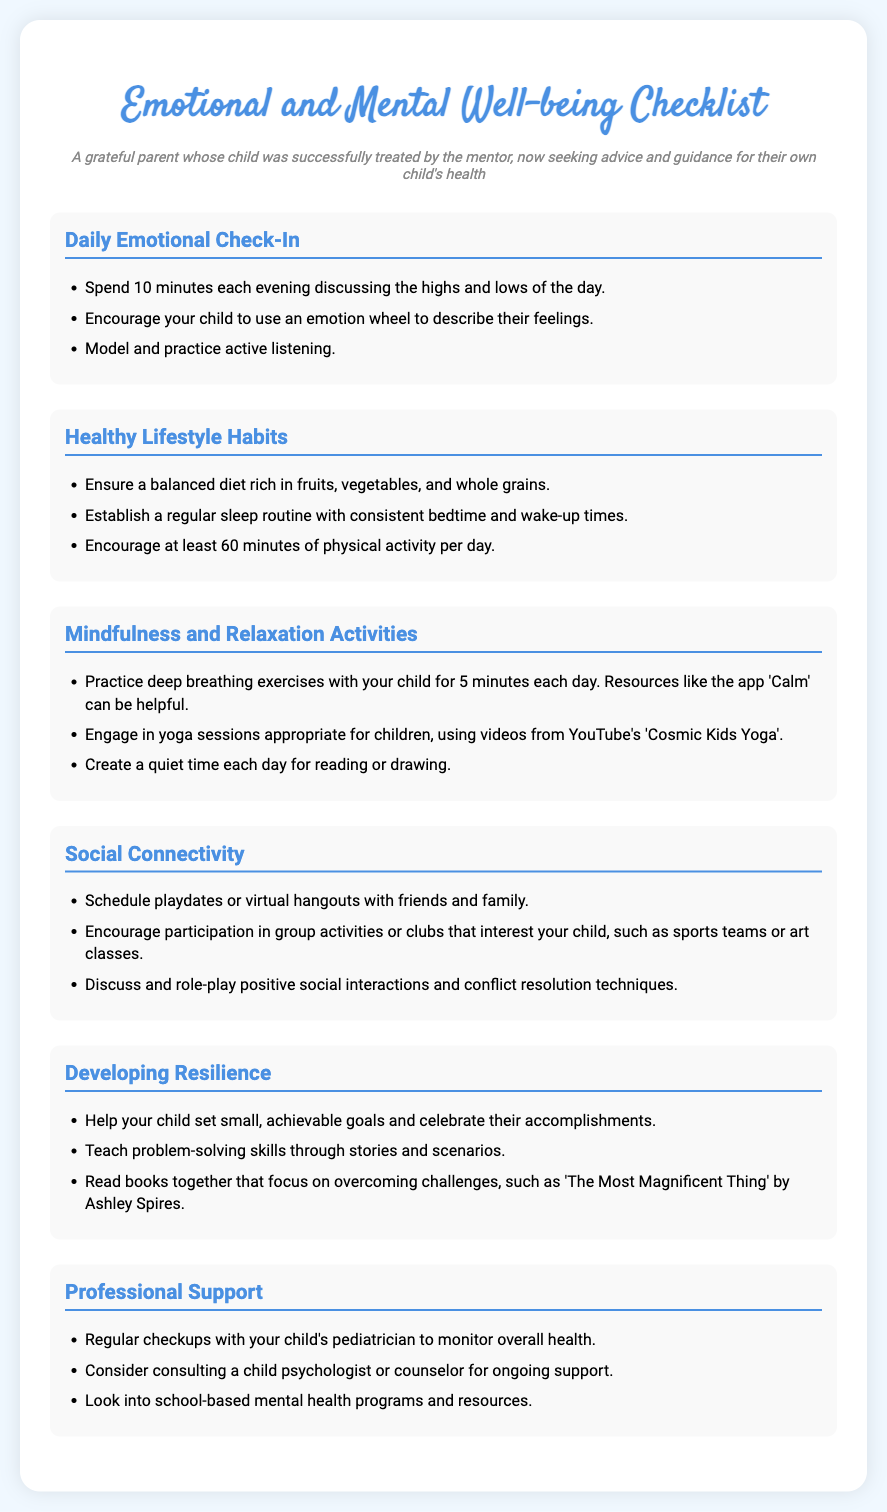what is the title of the document? The title is prominently displayed at the top of the document, indicating its main subject.
Answer: Emotional and Mental Well-being Checklist how many sections are there in the checklist? The document lists individual sections, which can be counted to find the total.
Answer: 6 what activity is recommended for daily emotional check-in? Each section provides specific activities that can be performed to enhance emotional well-being.
Answer: Discuss the highs and lows of the day which resource is suggested for deep breathing exercises? The document references a specific app that may help facilitate mindfulness activities.
Answer: Calm what type of activities should be encouraged for social connectivity? The document describes types of interactions that support children's social skills.
Answer: Playdates what is one book mentioned to help develop resilience? The document suggests specific literature that deals with overcoming challenges to bolster resilience.
Answer: The Most Magnificent Thing what is the recommended duration of physical activity per day? The official recommendations for physical activity duration for children are mentioned in the health habits section.
Answer: 60 minutes what professional support is suggested for ongoing mental health? The checklist highlights various forms of professional assistance that can be sought for children's mental health.
Answer: Child psychologist or counselor 